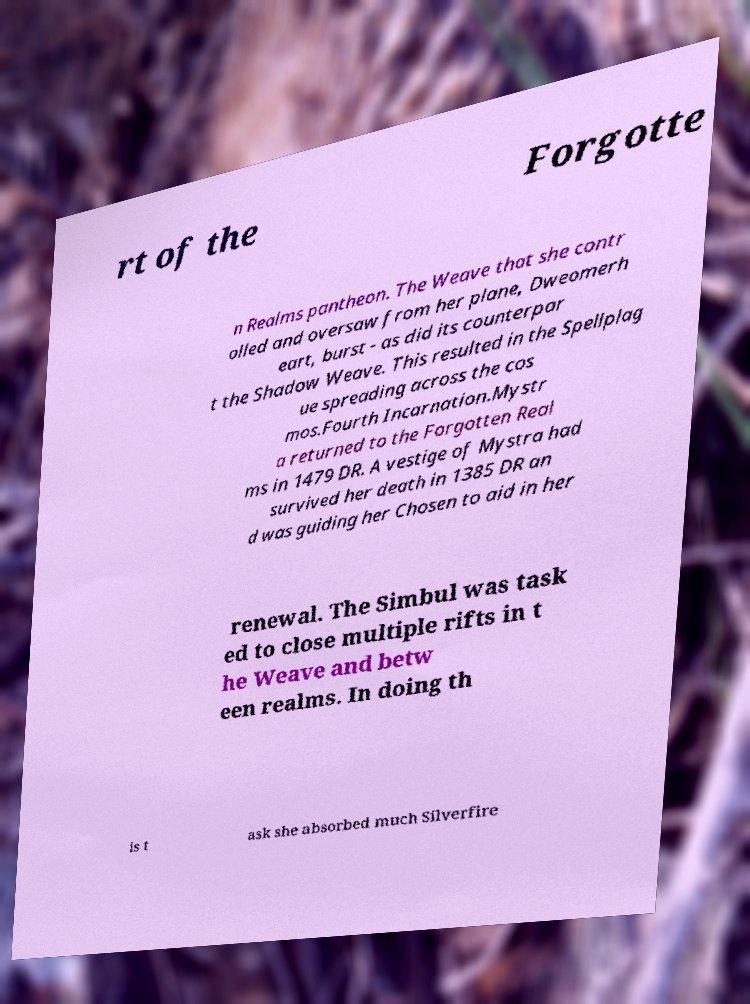Please read and relay the text visible in this image. What does it say? rt of the Forgotte n Realms pantheon. The Weave that she contr olled and oversaw from her plane, Dweomerh eart, burst - as did its counterpar t the Shadow Weave. This resulted in the Spellplag ue spreading across the cos mos.Fourth Incarnation.Mystr a returned to the Forgotten Real ms in 1479 DR. A vestige of Mystra had survived her death in 1385 DR an d was guiding her Chosen to aid in her renewal. The Simbul was task ed to close multiple rifts in t he Weave and betw een realms. In doing th is t ask she absorbed much Silverfire 